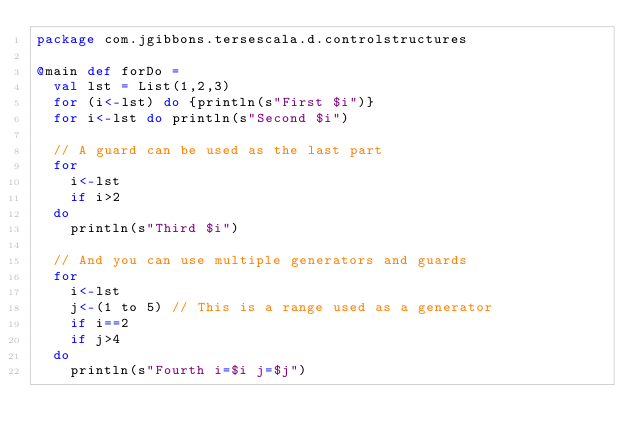Convert code to text. <code><loc_0><loc_0><loc_500><loc_500><_Scala_>package com.jgibbons.tersescala.d.controlstructures

@main def forDo =
  val lst = List(1,2,3)
  for (i<-lst) do {println(s"First $i")}
  for i<-lst do println(s"Second $i")

  // A guard can be used as the last part
  for
    i<-lst
    if i>2
  do
    println(s"Third $i")

  // And you can use multiple generators and guards
  for
    i<-lst
    j<-(1 to 5) // This is a range used as a generator
    if i==2
    if j>4
  do
    println(s"Fourth i=$i j=$j")
</code> 